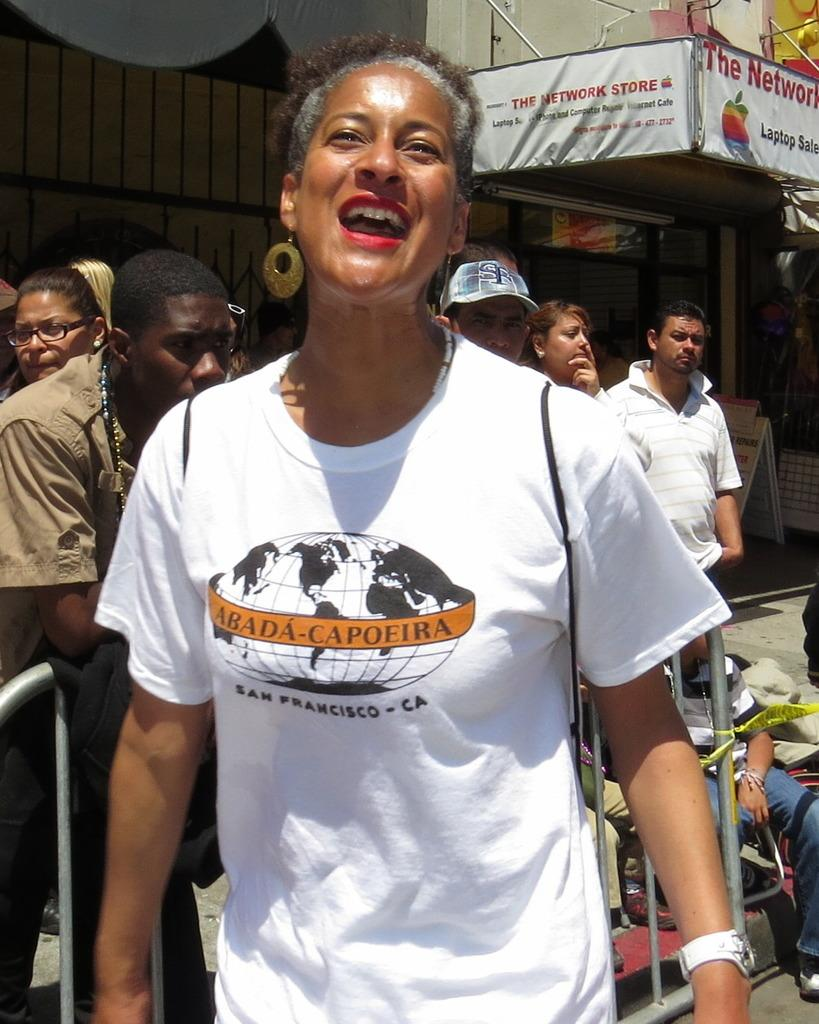What are the people in the image wearing? The people in the image are wearing different color dresses. What type of structures can be seen in the image? There are buildings in the image. What are the boards used for in the image? The purpose of the boards in the image is not specified, but they are visible. What material are the walls made of in the image? The walls in the image are made of glass. Can you describe any other objects present in the image? There are other objects in the image, but their specific details are not mentioned in the provided facts. What type of mine is visible in the image? There is no mine present in the image. How does the throat of the person in the image look? The image does not show the throat of any person, so it cannot be described. 